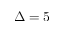<formula> <loc_0><loc_0><loc_500><loc_500>\Delta = 5</formula> 